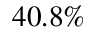Convert formula to latex. <formula><loc_0><loc_0><loc_500><loc_500>4 0 . 8 \%</formula> 